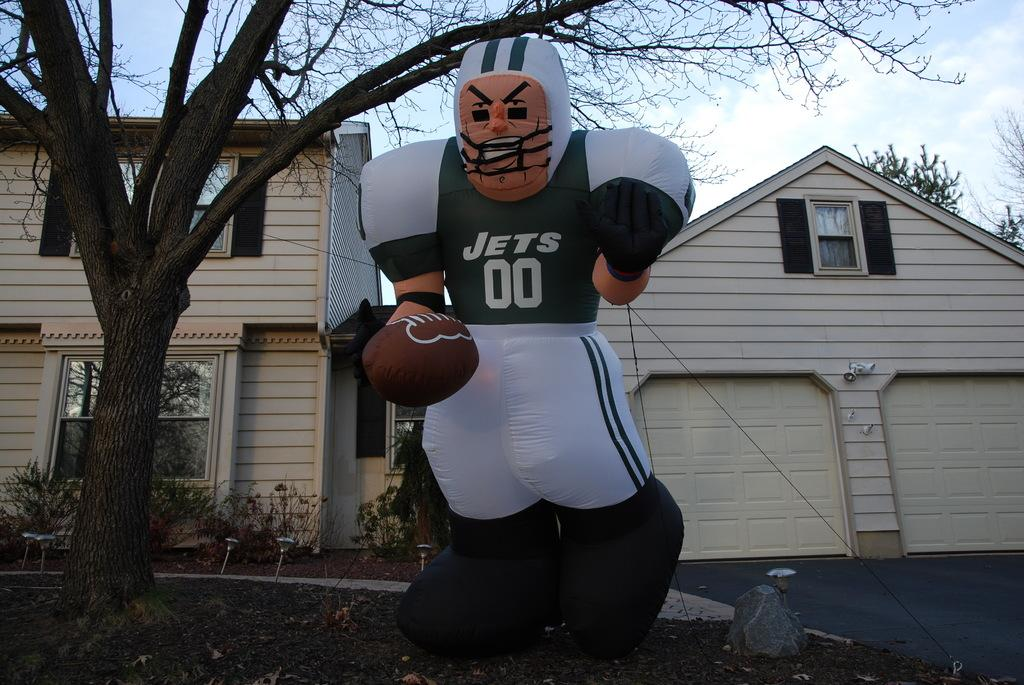<image>
Describe the image concisely. A New York Jets blow up stands in front of a suburban home. 